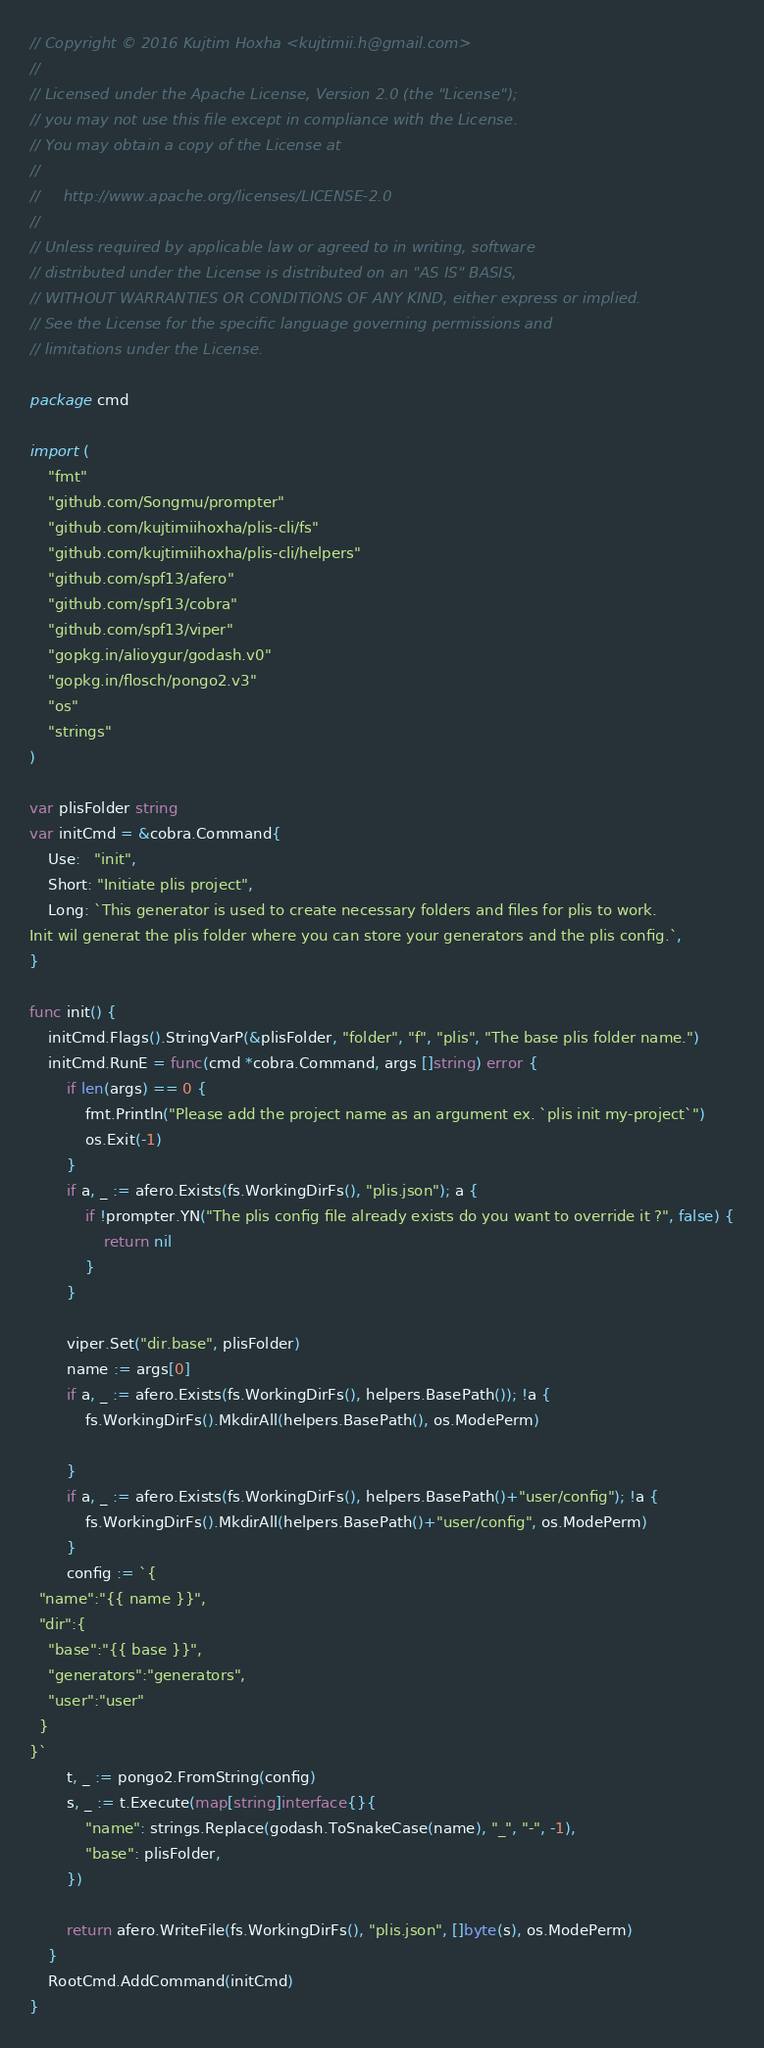Convert code to text. <code><loc_0><loc_0><loc_500><loc_500><_Go_>// Copyright © 2016 Kujtim Hoxha <kujtimii.h@gmail.com>
//
// Licensed under the Apache License, Version 2.0 (the "License");
// you may not use this file except in compliance with the License.
// You may obtain a copy of the License at
//
//     http://www.apache.org/licenses/LICENSE-2.0
//
// Unless required by applicable law or agreed to in writing, software
// distributed under the License is distributed on an "AS IS" BASIS,
// WITHOUT WARRANTIES OR CONDITIONS OF ANY KIND, either express or implied.
// See the License for the specific language governing permissions and
// limitations under the License.

package cmd

import (
	"fmt"
	"github.com/Songmu/prompter"
	"github.com/kujtimiihoxha/plis-cli/fs"
	"github.com/kujtimiihoxha/plis-cli/helpers"
	"github.com/spf13/afero"
	"github.com/spf13/cobra"
	"github.com/spf13/viper"
	"gopkg.in/alioygur/godash.v0"
	"gopkg.in/flosch/pongo2.v3"
	"os"
	"strings"
)

var plisFolder string
var initCmd = &cobra.Command{
	Use:   "init",
	Short: "Initiate plis project",
	Long: `This generator is used to create necessary folders and files for plis to work.
Init wil generat the plis folder where you can store your generators and the plis config.`,
}

func init() {
	initCmd.Flags().StringVarP(&plisFolder, "folder", "f", "plis", "The base plis folder name.")
	initCmd.RunE = func(cmd *cobra.Command, args []string) error {
		if len(args) == 0 {
			fmt.Println("Please add the project name as an argument ex. `plis init my-project`")
			os.Exit(-1)
		}
		if a, _ := afero.Exists(fs.WorkingDirFs(), "plis.json"); a {
			if !prompter.YN("The plis config file already exists do you want to override it ?", false) {
				return nil
			}
		}

		viper.Set("dir.base", plisFolder)
		name := args[0]
		if a, _ := afero.Exists(fs.WorkingDirFs(), helpers.BasePath()); !a {
			fs.WorkingDirFs().MkdirAll(helpers.BasePath(), os.ModePerm)

		}
		if a, _ := afero.Exists(fs.WorkingDirFs(), helpers.BasePath()+"user/config"); !a {
			fs.WorkingDirFs().MkdirAll(helpers.BasePath()+"user/config", os.ModePerm)
		}
		config := `{
  "name":"{{ name }}",
  "dir":{
    "base":"{{ base }}",
    "generators":"generators",
    "user":"user"
  }
}`
		t, _ := pongo2.FromString(config)
		s, _ := t.Execute(map[string]interface{}{
			"name": strings.Replace(godash.ToSnakeCase(name), "_", "-", -1),
			"base": plisFolder,
		})

		return afero.WriteFile(fs.WorkingDirFs(), "plis.json", []byte(s), os.ModePerm)
	}
	RootCmd.AddCommand(initCmd)
}
</code> 